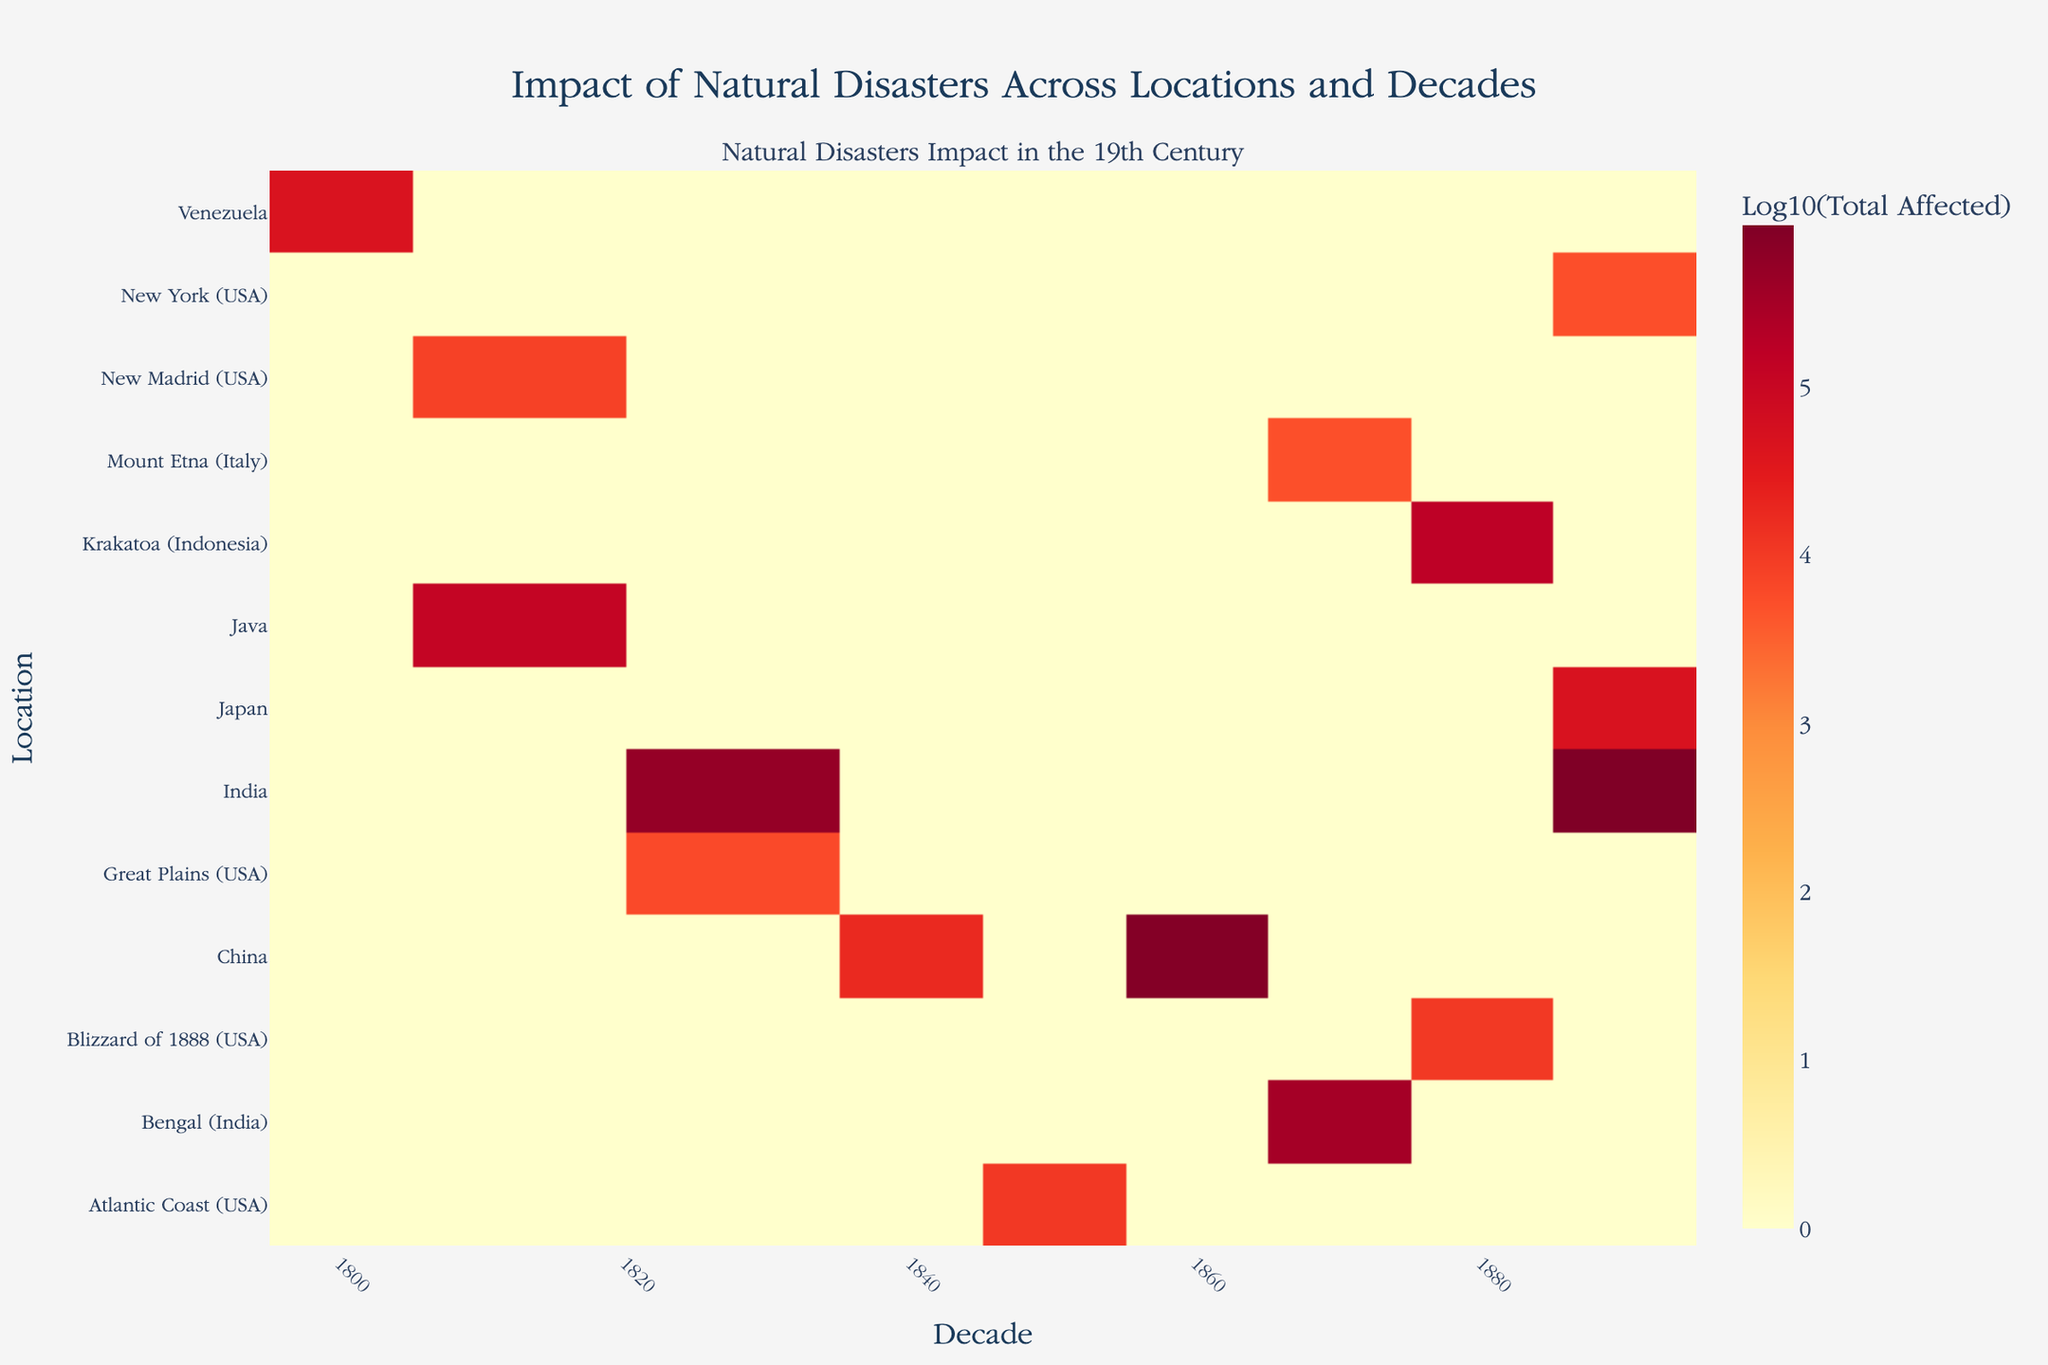What's the title of the heatmap? The title of the heatmap is displayed prominently at the top of the figure.
Answer: Impact of Natural Disasters Across Locations and Decades Which location has the highest log10 total affected in the 1890s? Look for the darkest cell in the column representing the 1890s and observe the y-axis for the corresponding location.
Answer: India What does the color intensity represent in the heatmap? The color intensity represents the log10 of the total number of people affected (deaths + displaced population) by natural disasters in different locations and decades. Brighter colors indicate higher affected numbers.
Answer: Log10(Total Affected) How are the axes labeled on the heatmap? Examine the labels along the x-axis and y-axis. The x-axis label is below the heatmap and the y-axis label is to the left.
Answer: The x-axis is labeled "Decade" and the y-axis is labeled "Location." Which decade saw the highest total affected in Venezuela? Find the row corresponding to Venezuela on the y-axis and identify the decade with the darkest color cell in that row.
Answer: 1800s What is the trend of natural disasters impact in China throughout the 19th century? Observe the color pattern along the row for China over different decades, and note any significant changes in color intensity.
Answer: Significant impact in the 1860s, relatively lower in other decades Which location had the least impact in the 1870s? Identify the column for the 1870s and find the cell with the lightest color to determine the corresponding location on the y-axis.
Answer: Mount Etna (Italy) Compare the number of total affected people in the 1800s in Venezuela and the USA. Which is higher? Compare the color intensity in the 1800s column for both Venezuela and USA, noting that higher intensity means a higher number.
Answer: Venezuela How does the impact of natural disasters in India in the 1880s compare to the 1890s? Check the color intensity for India in the 1880s and 1890s columns, and note which decade has a brighter color.
Answer: More in the 1890s Which decade had the highest average total affected across all locations? Average the color intensities (log10 values) of all cells in each decade column and compare the values to find the highest one.
Answer: 1860s 